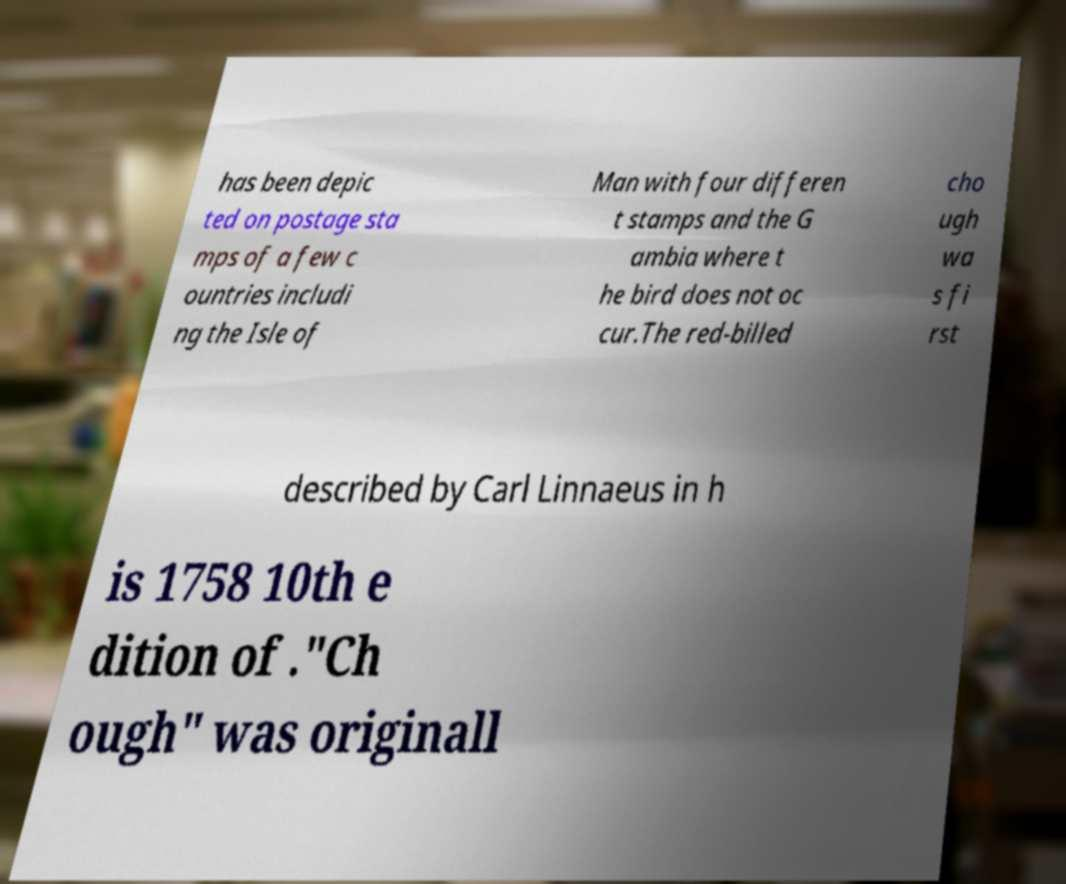What messages or text are displayed in this image? I need them in a readable, typed format. has been depic ted on postage sta mps of a few c ountries includi ng the Isle of Man with four differen t stamps and the G ambia where t he bird does not oc cur.The red-billed cho ugh wa s fi rst described by Carl Linnaeus in h is 1758 10th e dition of ."Ch ough" was originall 